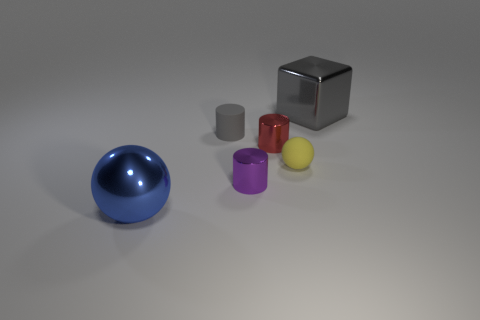There is a tiny object that is to the left of the tiny red thing and in front of the gray matte thing; what is its material?
Your response must be concise. Metal. Does the metallic block have the same size as the matte object that is to the right of the small gray rubber thing?
Give a very brief answer. No. Are there any brown matte cubes?
Keep it short and to the point. No. There is a tiny red object that is the same shape as the small purple shiny object; what material is it?
Ensure brevity in your answer.  Metal. There is a sphere to the left of the tiny gray cylinder that is behind the large thing that is in front of the large gray cube; what is its size?
Offer a very short reply. Large. There is a red thing; are there any small yellow balls behind it?
Provide a short and direct response. No. The gray thing that is the same material as the small yellow object is what size?
Provide a succinct answer. Small. What number of tiny gray matte objects are the same shape as the small red metal object?
Offer a very short reply. 1. Are the blue thing and the gray object that is on the left side of the large gray shiny object made of the same material?
Offer a very short reply. No. Are there more red cylinders that are in front of the blue metallic object than large green rubber objects?
Make the answer very short. No. 